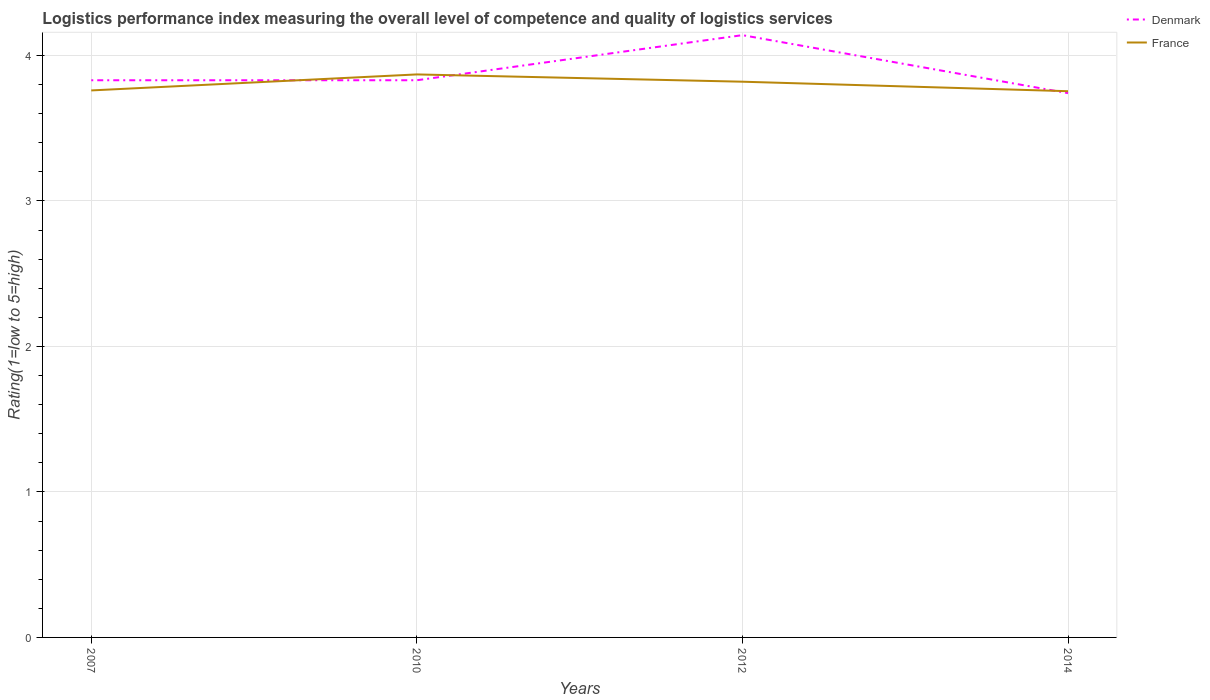Does the line corresponding to Denmark intersect with the line corresponding to France?
Make the answer very short. Yes. Across all years, what is the maximum Logistic performance index in France?
Your answer should be very brief. 3.75. In which year was the Logistic performance index in France maximum?
Your response must be concise. 2014. What is the total Logistic performance index in France in the graph?
Offer a very short reply. 0.07. What is the difference between the highest and the second highest Logistic performance index in France?
Your answer should be very brief. 0.12. How many lines are there?
Give a very brief answer. 2. What is the difference between two consecutive major ticks on the Y-axis?
Provide a short and direct response. 1. Are the values on the major ticks of Y-axis written in scientific E-notation?
Offer a terse response. No. Does the graph contain any zero values?
Give a very brief answer. No. Where does the legend appear in the graph?
Your response must be concise. Top right. What is the title of the graph?
Offer a terse response. Logistics performance index measuring the overall level of competence and quality of logistics services. Does "Channel Islands" appear as one of the legend labels in the graph?
Make the answer very short. No. What is the label or title of the Y-axis?
Ensure brevity in your answer.  Rating(1=low to 5=high). What is the Rating(1=low to 5=high) of Denmark in 2007?
Provide a succinct answer. 3.83. What is the Rating(1=low to 5=high) in France in 2007?
Provide a succinct answer. 3.76. What is the Rating(1=low to 5=high) in Denmark in 2010?
Your response must be concise. 3.83. What is the Rating(1=low to 5=high) in France in 2010?
Offer a very short reply. 3.87. What is the Rating(1=low to 5=high) in Denmark in 2012?
Keep it short and to the point. 4.14. What is the Rating(1=low to 5=high) in France in 2012?
Provide a succinct answer. 3.82. What is the Rating(1=low to 5=high) of Denmark in 2014?
Your answer should be compact. 3.74. What is the Rating(1=low to 5=high) of France in 2014?
Keep it short and to the point. 3.75. Across all years, what is the maximum Rating(1=low to 5=high) in Denmark?
Provide a succinct answer. 4.14. Across all years, what is the maximum Rating(1=low to 5=high) of France?
Offer a very short reply. 3.87. Across all years, what is the minimum Rating(1=low to 5=high) in Denmark?
Offer a very short reply. 3.74. Across all years, what is the minimum Rating(1=low to 5=high) in France?
Your answer should be compact. 3.75. What is the total Rating(1=low to 5=high) in Denmark in the graph?
Provide a succinct answer. 15.54. What is the total Rating(1=low to 5=high) of France in the graph?
Provide a short and direct response. 15.2. What is the difference between the Rating(1=low to 5=high) in Denmark in 2007 and that in 2010?
Keep it short and to the point. 0. What is the difference between the Rating(1=low to 5=high) of France in 2007 and that in 2010?
Your response must be concise. -0.11. What is the difference between the Rating(1=low to 5=high) of Denmark in 2007 and that in 2012?
Provide a short and direct response. -0.31. What is the difference between the Rating(1=low to 5=high) in France in 2007 and that in 2012?
Offer a very short reply. -0.06. What is the difference between the Rating(1=low to 5=high) of Denmark in 2007 and that in 2014?
Make the answer very short. 0.09. What is the difference between the Rating(1=low to 5=high) in France in 2007 and that in 2014?
Give a very brief answer. 0.01. What is the difference between the Rating(1=low to 5=high) of Denmark in 2010 and that in 2012?
Your response must be concise. -0.31. What is the difference between the Rating(1=low to 5=high) of France in 2010 and that in 2012?
Offer a very short reply. 0.05. What is the difference between the Rating(1=low to 5=high) in Denmark in 2010 and that in 2014?
Provide a succinct answer. 0.09. What is the difference between the Rating(1=low to 5=high) of France in 2010 and that in 2014?
Provide a succinct answer. 0.12. What is the difference between the Rating(1=low to 5=high) in Denmark in 2012 and that in 2014?
Make the answer very short. 0.4. What is the difference between the Rating(1=low to 5=high) in France in 2012 and that in 2014?
Give a very brief answer. 0.07. What is the difference between the Rating(1=low to 5=high) of Denmark in 2007 and the Rating(1=low to 5=high) of France in 2010?
Ensure brevity in your answer.  -0.04. What is the difference between the Rating(1=low to 5=high) in Denmark in 2007 and the Rating(1=low to 5=high) in France in 2014?
Your answer should be very brief. 0.08. What is the difference between the Rating(1=low to 5=high) of Denmark in 2010 and the Rating(1=low to 5=high) of France in 2014?
Ensure brevity in your answer.  0.08. What is the difference between the Rating(1=low to 5=high) of Denmark in 2012 and the Rating(1=low to 5=high) of France in 2014?
Give a very brief answer. 0.39. What is the average Rating(1=low to 5=high) of Denmark per year?
Your response must be concise. 3.89. What is the average Rating(1=low to 5=high) in France per year?
Make the answer very short. 3.8. In the year 2007, what is the difference between the Rating(1=low to 5=high) in Denmark and Rating(1=low to 5=high) in France?
Your answer should be compact. 0.07. In the year 2010, what is the difference between the Rating(1=low to 5=high) of Denmark and Rating(1=low to 5=high) of France?
Your answer should be very brief. -0.04. In the year 2012, what is the difference between the Rating(1=low to 5=high) in Denmark and Rating(1=low to 5=high) in France?
Provide a succinct answer. 0.32. In the year 2014, what is the difference between the Rating(1=low to 5=high) in Denmark and Rating(1=low to 5=high) in France?
Keep it short and to the point. -0.01. What is the ratio of the Rating(1=low to 5=high) in France in 2007 to that in 2010?
Your response must be concise. 0.97. What is the ratio of the Rating(1=low to 5=high) in Denmark in 2007 to that in 2012?
Your answer should be compact. 0.93. What is the ratio of the Rating(1=low to 5=high) of France in 2007 to that in 2012?
Your response must be concise. 0.98. What is the ratio of the Rating(1=low to 5=high) of Denmark in 2007 to that in 2014?
Provide a succinct answer. 1.02. What is the ratio of the Rating(1=low to 5=high) in Denmark in 2010 to that in 2012?
Your answer should be compact. 0.93. What is the ratio of the Rating(1=low to 5=high) in France in 2010 to that in 2012?
Make the answer very short. 1.01. What is the ratio of the Rating(1=low to 5=high) of Denmark in 2010 to that in 2014?
Give a very brief answer. 1.02. What is the ratio of the Rating(1=low to 5=high) in France in 2010 to that in 2014?
Provide a succinct answer. 1.03. What is the ratio of the Rating(1=low to 5=high) in Denmark in 2012 to that in 2014?
Ensure brevity in your answer.  1.11. What is the ratio of the Rating(1=low to 5=high) of France in 2012 to that in 2014?
Make the answer very short. 1.02. What is the difference between the highest and the second highest Rating(1=low to 5=high) of Denmark?
Keep it short and to the point. 0.31. What is the difference between the highest and the second highest Rating(1=low to 5=high) in France?
Keep it short and to the point. 0.05. What is the difference between the highest and the lowest Rating(1=low to 5=high) in Denmark?
Ensure brevity in your answer.  0.4. What is the difference between the highest and the lowest Rating(1=low to 5=high) of France?
Your answer should be compact. 0.12. 